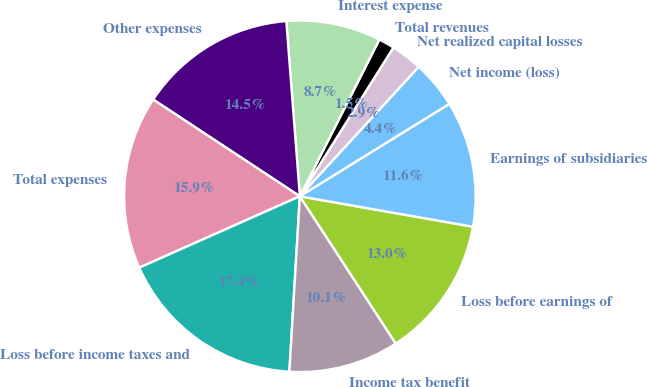Convert chart. <chart><loc_0><loc_0><loc_500><loc_500><pie_chart><fcel>Net realized capital losses<fcel>Total revenues<fcel>Interest expense<fcel>Other expenses<fcel>Total expenses<fcel>Loss before income taxes and<fcel>Income tax benefit<fcel>Loss before earnings of<fcel>Earnings of subsidiaries<fcel>Net income (loss)<nl><fcel>2.9%<fcel>1.46%<fcel>8.7%<fcel>14.49%<fcel>15.94%<fcel>17.39%<fcel>10.14%<fcel>13.04%<fcel>11.59%<fcel>4.35%<nl></chart> 